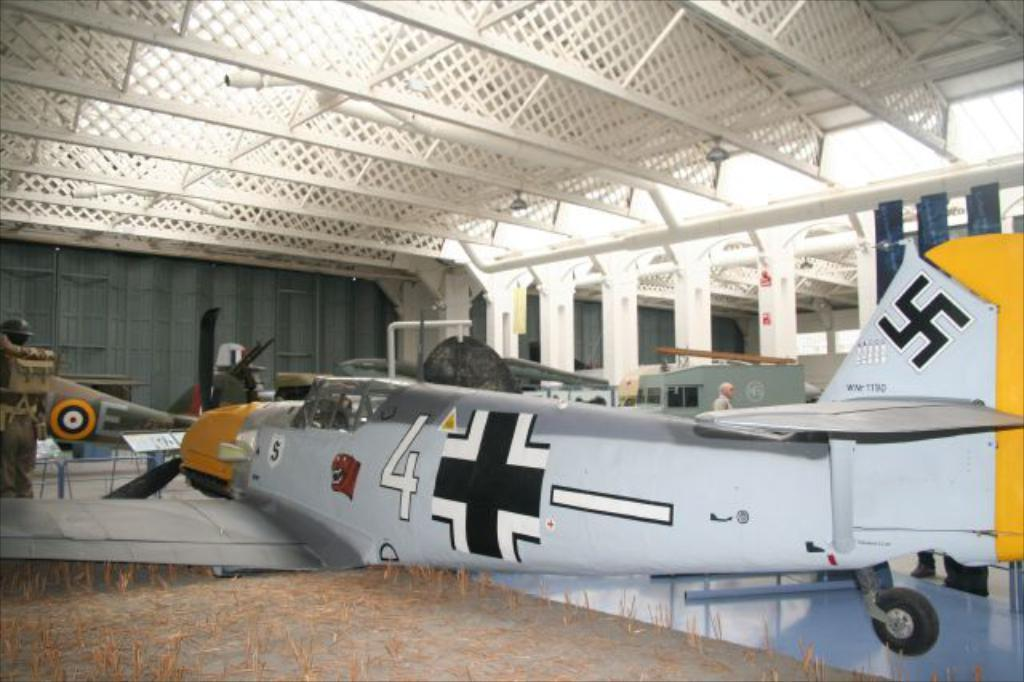What is the main subject of the image? The main subject of the image is an aircraft. What colors are used to paint the aircraft? The aircraft is in white and yellow color. Can you describe the background of the image? There is a person standing in the background of the image, along with lights and other objects. Where is the goldfish swimming in the image? There is no goldfish present in the image. How does the power of the aircraft affect its performance in the image? The image does not provide any information about the power of the aircraft or its performance. 